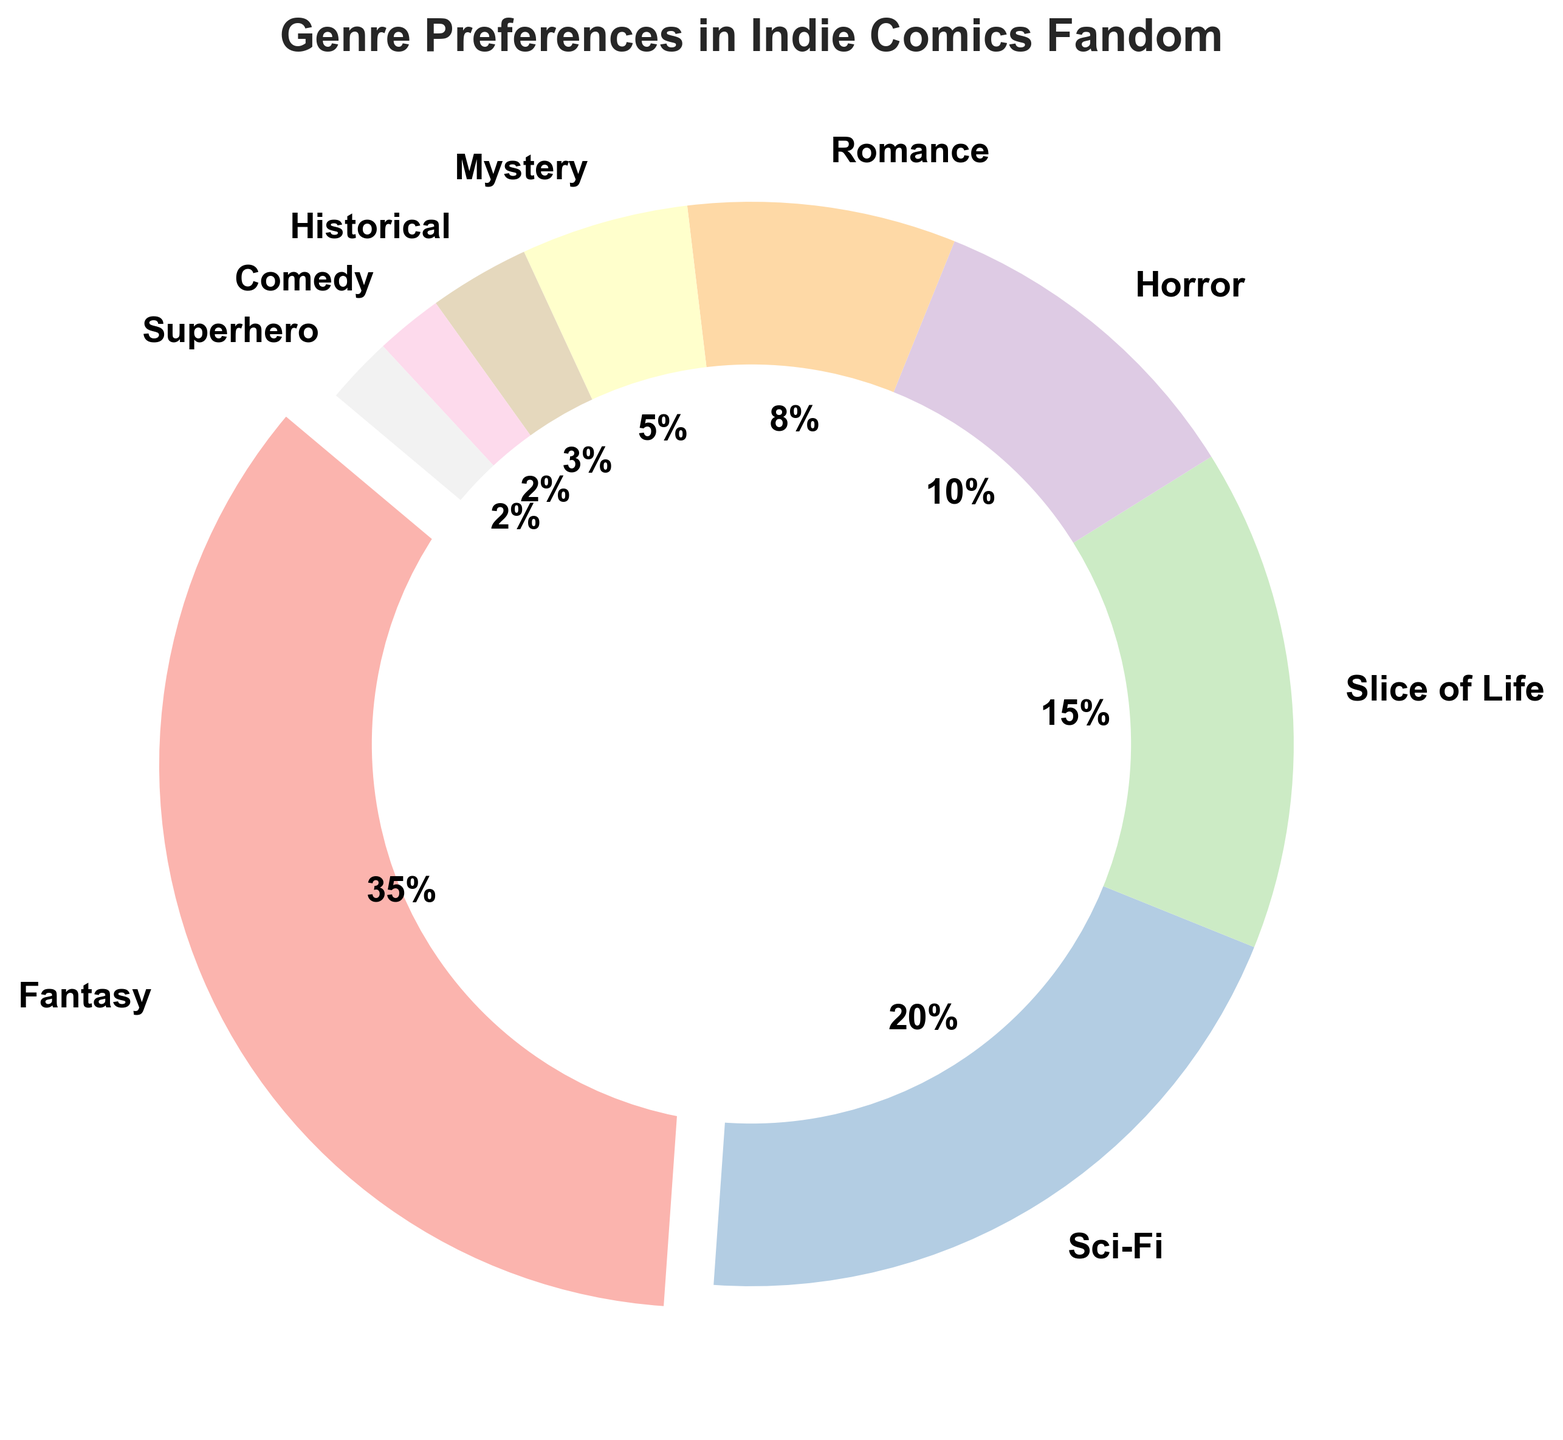What genre has the highest percentage in the Indie Comics Fandom? By looking at the pie chart, the largest slice is clearly labeled as "Fantasy" with 35%, indicating it has the highest percentage.
Answer: Fantasy Which two genres together make up a quarter of the Indie Comics Fandom? To find a quarter (25%) of the fandom, we look for the genres whose percentages add up to 25%. "Horror" at 10% and "Romance" at 8% together make 18%, and "Mystery" at 5% adds up to 23%, while "Historical" at 3% completes it to 26%. However, "Slice of Life" at 15% and "Mystery" at 10% sum exactly to 25%.
Answer: Slice of Life and Horror What is the difference in percentage between "Fantasy" and "Sci-Fi"? "Fantasy" is at 35% and "Sci-Fi" is at 20%. The difference between them is 35% - 20% = 15%.
Answer: 15% Which genre is represented by the smallest slice in the pie chart? The smallest slice in the pie chart belongs to a genre listed with 2%, which is divided between "Superhero" and "Comedy". Hence, they are equal, but technically the smallest one.
Answer: Superhero and Comedy How much larger is the percentage of "Fantasy" compared to "Horror"? "Fantasy" is at 35% and "Horror" is at 10%. The difference measures how much larger "Fantasy" is, which is 35% - 10% = 25%.
Answer: 25% What percentage of the Indie Comics Fandom is represented by "Romance" and "Historical" genres combined? By summing the percentages of "Romance" (8%) and "Historical" (3%), we get 8% + 3% = 11%.
Answer: 11% Are there any genres that each make up less than 5% of the fandom? If so, what are they? By observing the pie chart, the slices for "Historical" (3%), "Comedy" (2%), and "Superhero" (2%) each constitute less than 5%.
Answer: Historical, Comedy, Superhero What genres together make up exactly half of the Indie Comics Fandom? We need to sum the percentages of genres to reach 50%. "Fantasy" is 35%, adding "Sci-Fi" at 20% would reach 55%, which is over half. We need to try smaller combinations: "Fantasy" 35%, and combining "Slice of Life" at 15% which adds up to 50%.
Answer: Fantasy and Slice of Life If you exclude the "Fantasy" genre, what is the percentage for the largest remaining genre? By excluding "Fantasy" at 35%, the next largest slice is "Sci-Fi" at 20%.
Answer: Sci-Fi What is the total percentage of all the slices in the pie chart except for "Romance" and "Mystery"? First, we add the percentages of "Romance" (8%) and "Mystery" (5%) to get 13%. Then, subtract this sum from the total 100%: 100% - 13% = 87%.
Answer: 87% 